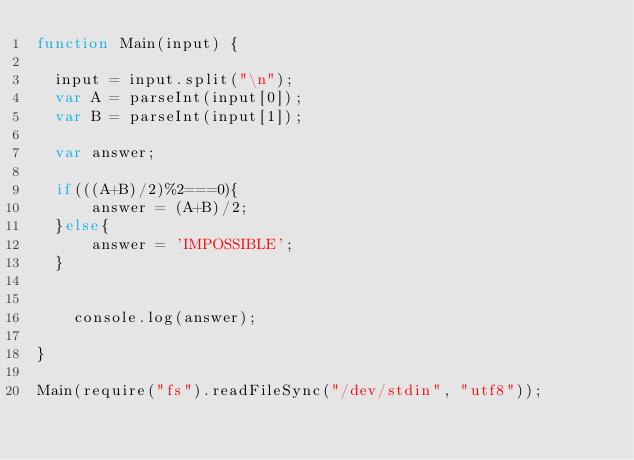<code> <loc_0><loc_0><loc_500><loc_500><_JavaScript_>function Main(input) {

	input = input.split("\n");
	var A = parseInt(input[0]);
	var B = parseInt(input[1]);
	
	var answer;
	
	if(((A+B)/2)%2===0){
	    answer = (A+B)/2;
	}else{
	    answer = 'IMPOSSIBLE';
	}

	
    console.log(answer);

}

Main(require("fs").readFileSync("/dev/stdin", "utf8"));</code> 